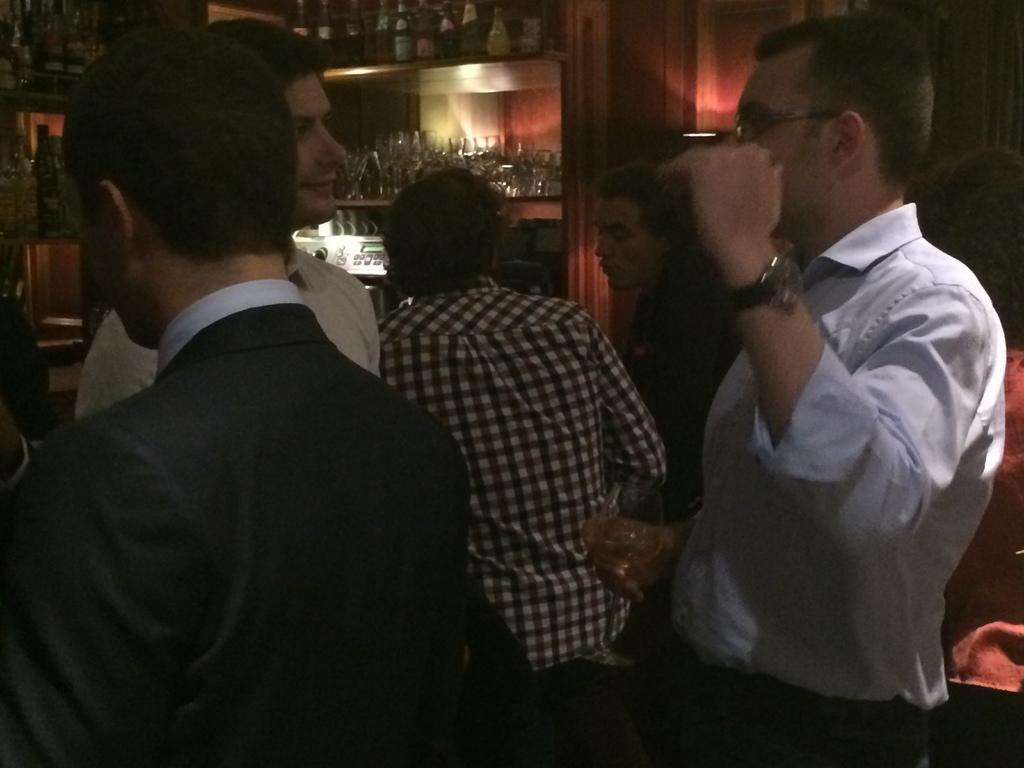How many people are in the image? There are people in the image, but the exact number is not specified. What is one person holding in the image? One person is holding a glass in the image. What can be seen on the racks in the image? There are glasses on racks and a bottle on racks in the image. What is visible in the background of the image? There is a wall visible in the image. What type of pen is being used by the person in the image? There is no pen present in the image. How many seats are visible in the image? There is no information about seats in the image. 